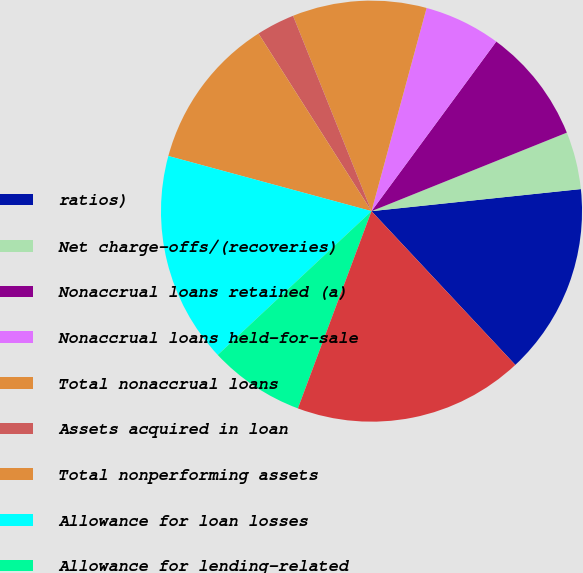Convert chart. <chart><loc_0><loc_0><loc_500><loc_500><pie_chart><fcel>ratios)<fcel>Net charge-offs/(recoveries)<fcel>Nonaccrual loans retained (a)<fcel>Nonaccrual loans held-for-sale<fcel>Total nonaccrual loans<fcel>Assets acquired in loan<fcel>Total nonperforming assets<fcel>Allowance for loan losses<fcel>Allowance for lending-related<fcel>Total allowance for credit<nl><fcel>14.7%<fcel>4.41%<fcel>8.82%<fcel>5.88%<fcel>10.29%<fcel>2.94%<fcel>11.76%<fcel>16.18%<fcel>7.35%<fcel>17.65%<nl></chart> 